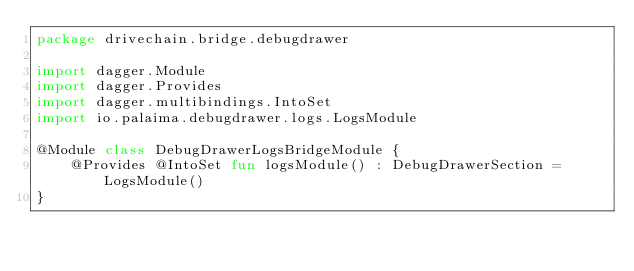Convert code to text. <code><loc_0><loc_0><loc_500><loc_500><_Kotlin_>package drivechain.bridge.debugdrawer

import dagger.Module
import dagger.Provides
import dagger.multibindings.IntoSet
import io.palaima.debugdrawer.logs.LogsModule

@Module class DebugDrawerLogsBridgeModule {
    @Provides @IntoSet fun logsModule() : DebugDrawerSection = LogsModule()
}
</code> 